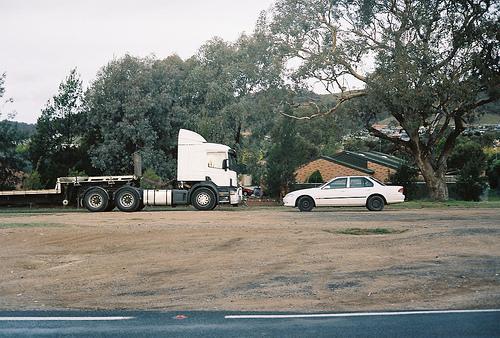How many vehicles are in the picture?
Give a very brief answer. 2. 